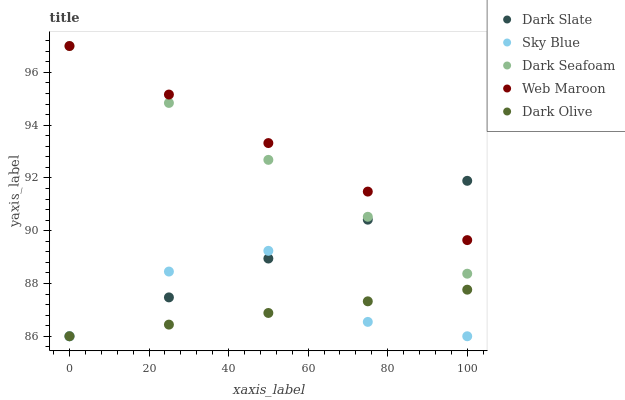Does Dark Olive have the minimum area under the curve?
Answer yes or no. Yes. Does Web Maroon have the maximum area under the curve?
Answer yes or no. Yes. Does Dark Seafoam have the minimum area under the curve?
Answer yes or no. No. Does Dark Seafoam have the maximum area under the curve?
Answer yes or no. No. Is Web Maroon the smoothest?
Answer yes or no. Yes. Is Sky Blue the roughest?
Answer yes or no. Yes. Is Dark Seafoam the smoothest?
Answer yes or no. No. Is Dark Seafoam the roughest?
Answer yes or no. No. Does Dark Slate have the lowest value?
Answer yes or no. Yes. Does Dark Seafoam have the lowest value?
Answer yes or no. No. Does Web Maroon have the highest value?
Answer yes or no. Yes. Does Dark Olive have the highest value?
Answer yes or no. No. Is Sky Blue less than Dark Seafoam?
Answer yes or no. Yes. Is Dark Seafoam greater than Sky Blue?
Answer yes or no. Yes. Does Sky Blue intersect Dark Slate?
Answer yes or no. Yes. Is Sky Blue less than Dark Slate?
Answer yes or no. No. Is Sky Blue greater than Dark Slate?
Answer yes or no. No. Does Sky Blue intersect Dark Seafoam?
Answer yes or no. No. 